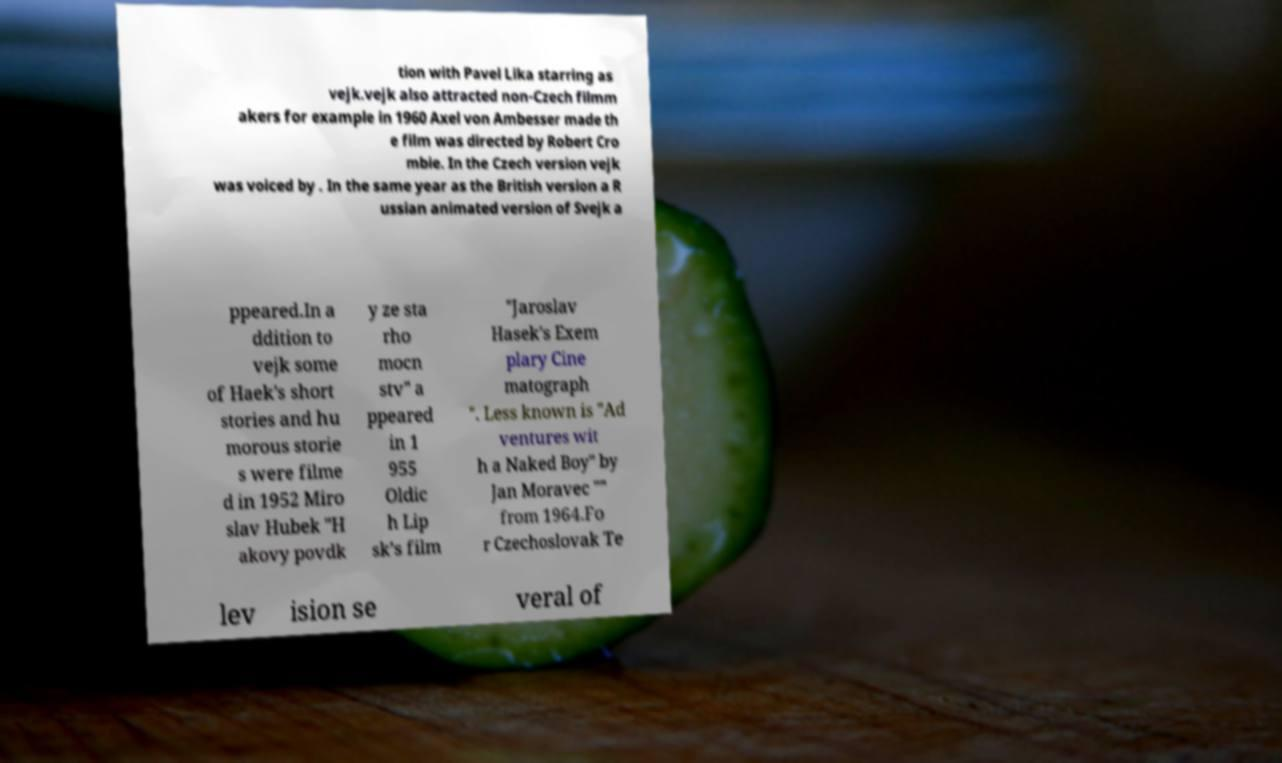Could you extract and type out the text from this image? tion with Pavel Lika starring as vejk.vejk also attracted non-Czech filmm akers for example in 1960 Axel von Ambesser made th e film was directed by Robert Cro mbie. In the Czech version vejk was voiced by . In the same year as the British version a R ussian animated version of Svejk a ppeared.In a ddition to vejk some of Haek's short stories and hu morous storie s were filme d in 1952 Miro slav Hubek "H akovy povdk y ze sta rho mocn stv" a ppeared in 1 955 Oldic h Lip sk’s film "Jaroslav Hasek's Exem plary Cine matograph ". Less known is "Ad ventures wit h a Naked Boy" by Jan Moravec "" from 1964.Fo r Czechoslovak Te lev ision se veral of 